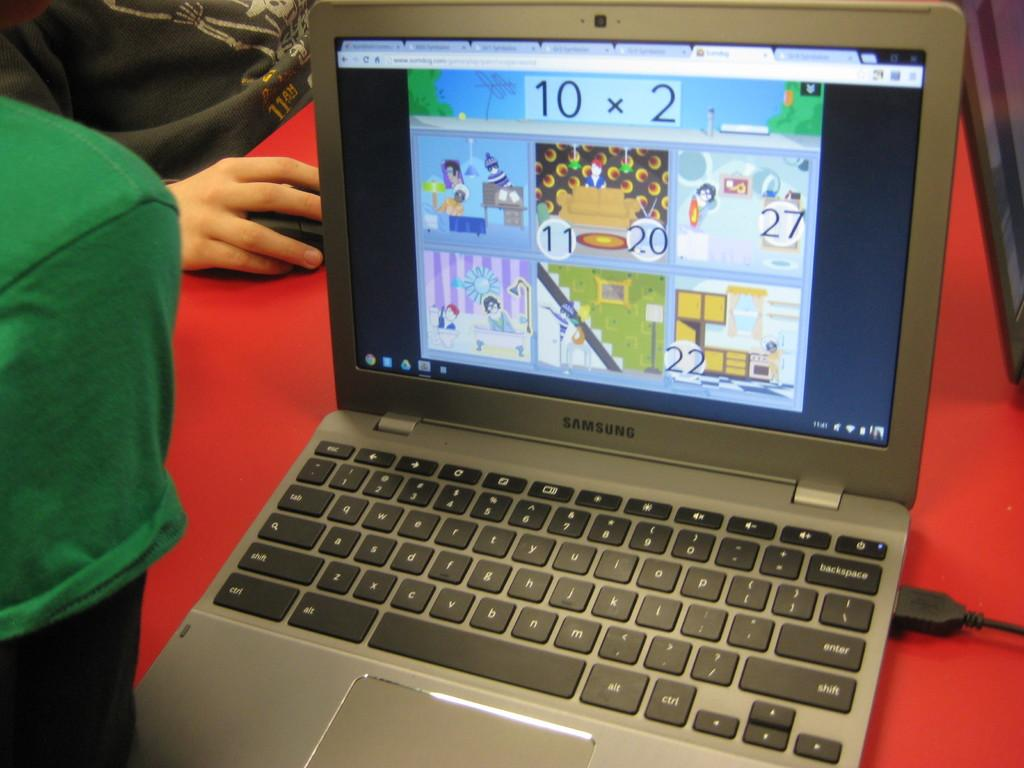<image>
Provide a brief description of the given image. 10x2 is the mathematical equation at the top of this laptop screen. 